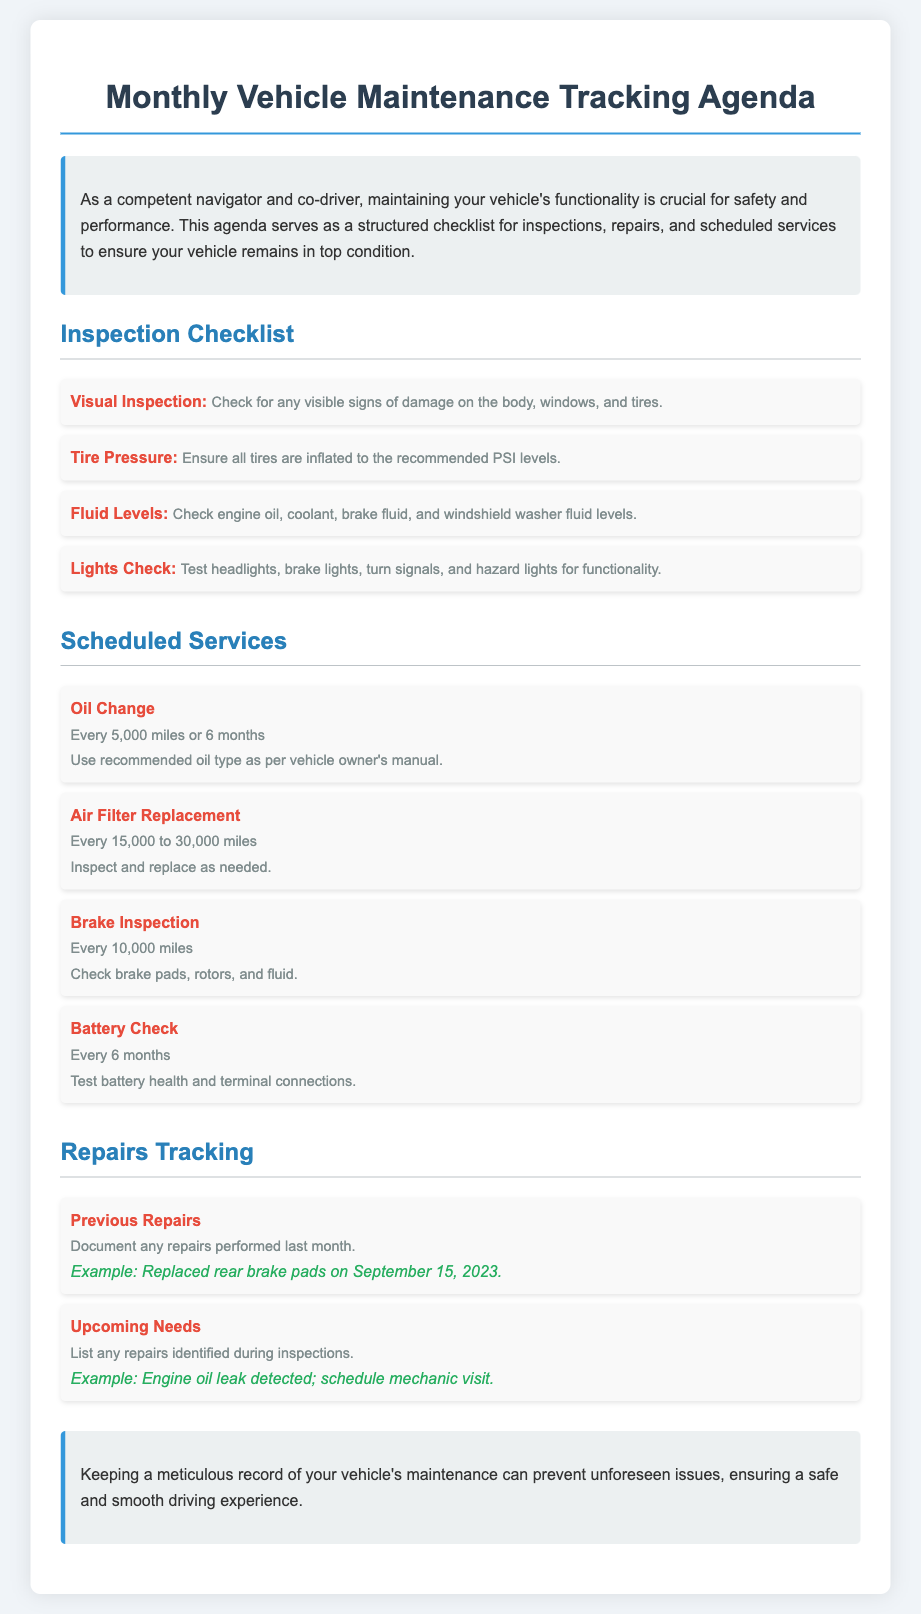What is the purpose of the agenda? The agenda serves as a structured checklist for inspections, repairs, and scheduled services to ensure your vehicle remains in top condition.
Answer: Structured checklist How often should the oil change be performed? The document specifies that the oil change should be done every 5,000 miles or 6 months.
Answer: Every 5,000 miles or 6 months What should be checked during the visual inspection? The visual inspection includes checking for any visible signs of damage on the body, windows, and tires.
Answer: Damage on the body, windows, and tires What is the recommended frequency for brake inspections? According to the agenda, brake inspections should be performed every 10,000 miles.
Answer: Every 10,000 miles What should be documented under previous repairs? The agenda states to document any repairs performed last month.
Answer: Repairs performed last month What example is given for upcoming repair needs? The document provides the example of an engine oil leak detected, which needs scheduling a mechanic visit.
Answer: Engine oil leak detected Which fluid levels should be checked? The fluid levels that should be checked include engine oil, coolant, brake fluid, and windshield washer fluid.
Answer: Engine oil, coolant, brake fluid, windshield washer fluid How often should the battery check be performed? The battery check should be conducted every 6 months as stated in the document.
Answer: Every 6 months What is the color of the section titles? The section titles are colored in a specific shade indicated in the styling, which is #2980b9 in the document.
Answer: #2980b9 